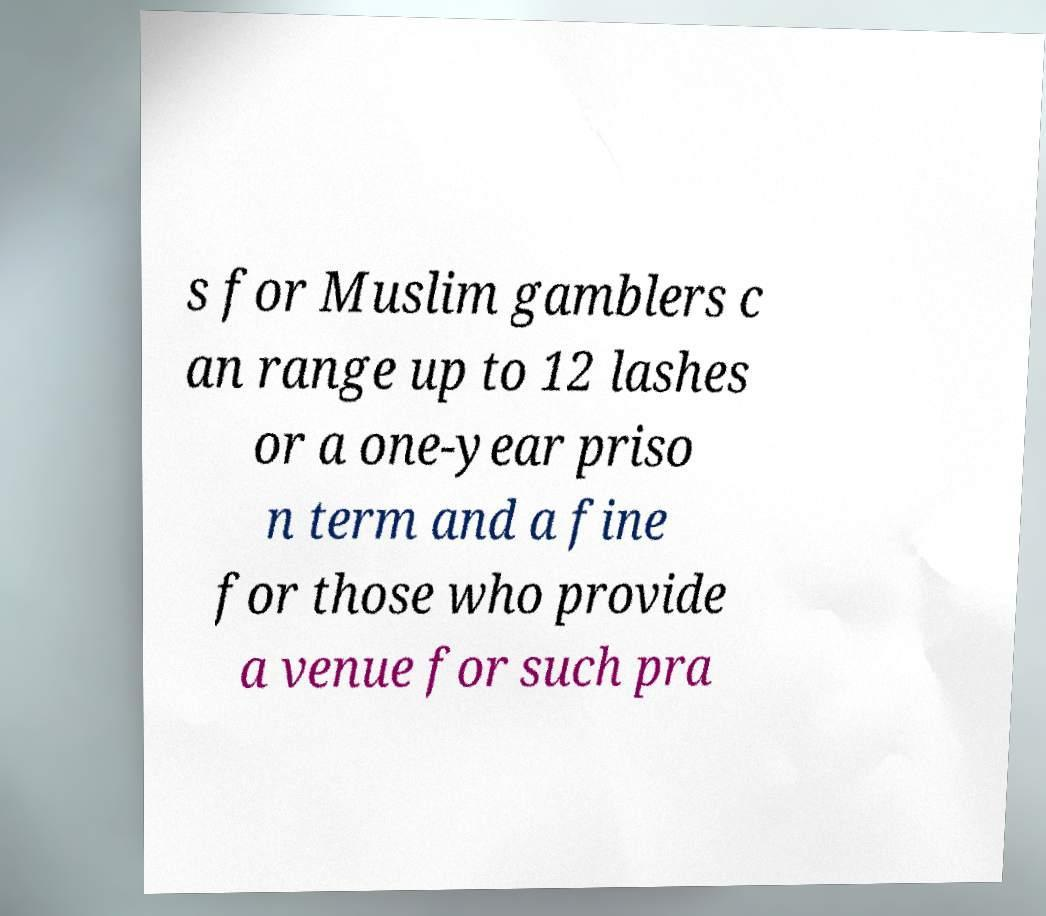Could you extract and type out the text from this image? s for Muslim gamblers c an range up to 12 lashes or a one-year priso n term and a fine for those who provide a venue for such pra 